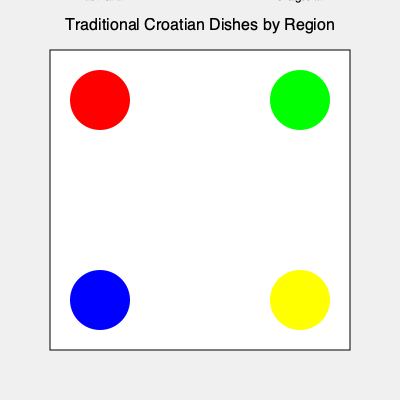Based on the map of traditional Croatian dishes by region, which area is known for its hearty, meat-based dishes and is represented by the green circle? To answer this question, we need to analyze the map and recall our knowledge of Croatian cuisine:

1. The map shows four main regions of Croatia: Istria, Slavonia, Dalmatia, and Zagreb.
2. Each region is represented by a colored circle:
   - Red: Istria
   - Green: Slavonia
   - Blue: Dalmatia
   - Yellow: Zagreb
3. We need to identify which of these regions is known for hearty, meat-based dishes.
4. Slavonia, located in the eastern part of Croatia, is famous for its rich, meat-heavy cuisine.
5. Slavonian dishes often include pork, game meats, and sausages like kulen.
6. On the map, Slavonia is represented by the green circle in the upper right corner.

Therefore, the region known for its hearty, meat-based dishes and represented by the green circle is Slavonia.
Answer: Slavonia 